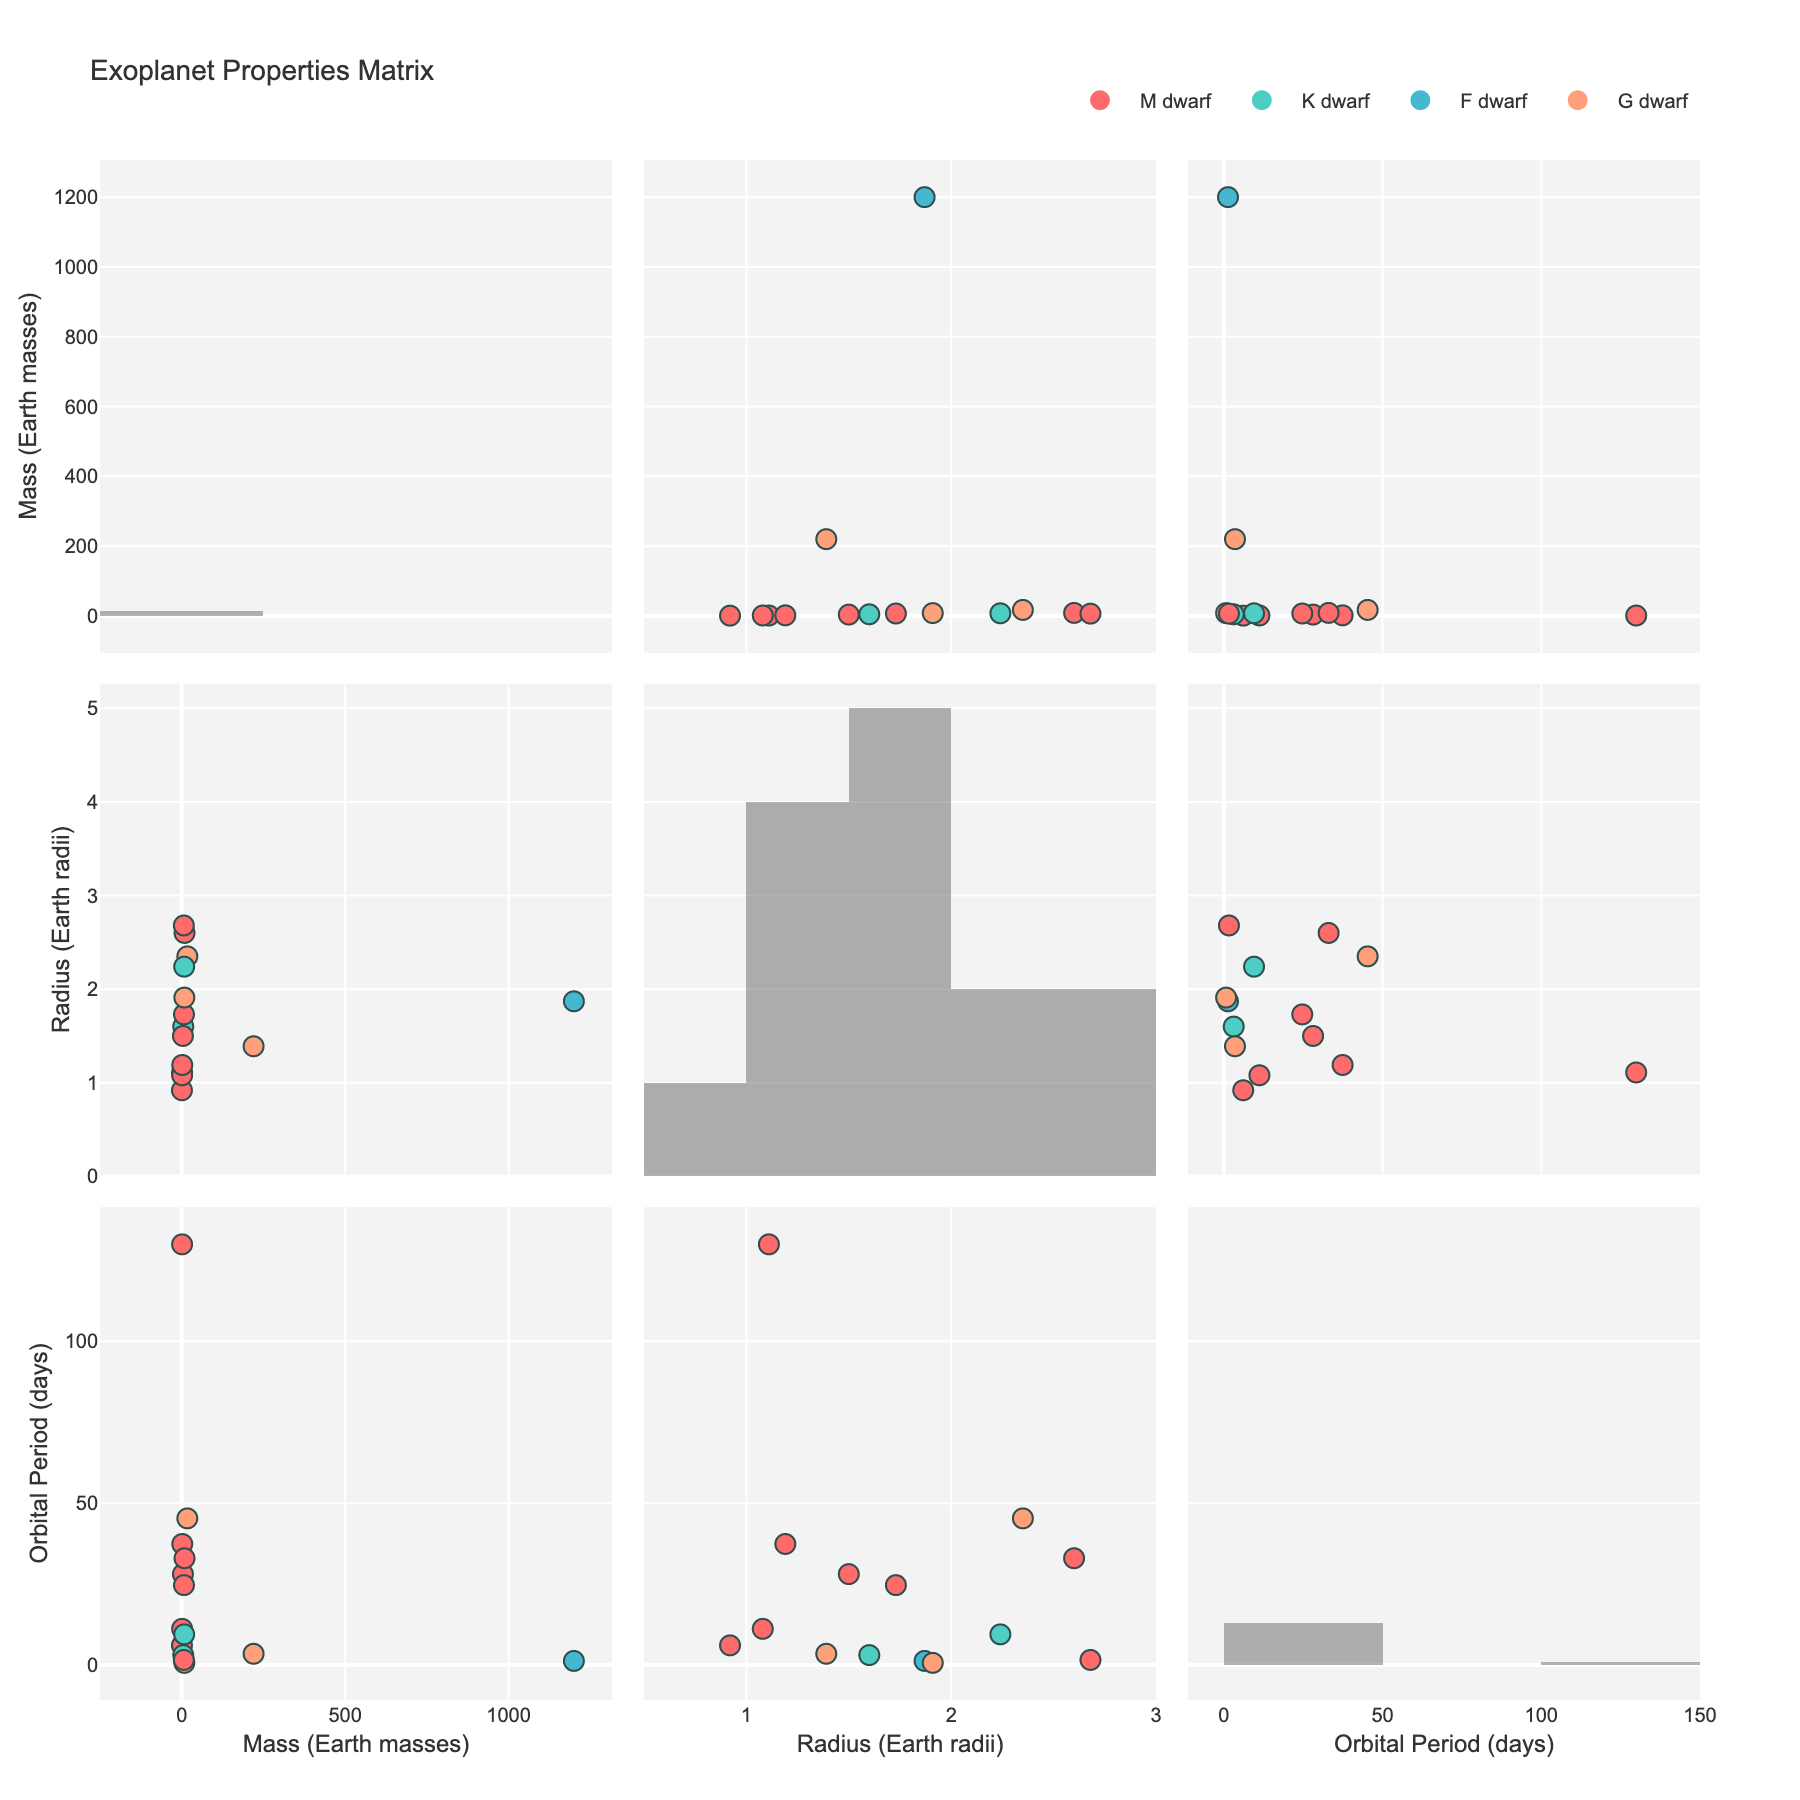what is the title of this plot? The title can be found at the top of the plot and it reads 'Exoplanet Properties Matrix'.
Answer: Exoplanet Properties Matrix How many M dwarf host stars are there? You can identify the M dwarf host stars by looking for the red markers within the figure. Counting these red markers gives the number of M dwarf host stars.
Answer: 9 Which planet has the shortest orbital period? By examining the Orbital Period (days) axis across the scatter plots and finding the smallest value, you can see that the planet with the shortest orbital period is 55 Cancri e.
Answer: 55 Cancri e What is the average radius of exoplanets orbiting G dwarf stars? To find the average radius, locate the exoplanets associated with G dwarf hosts by their color in the figure (peach-colored markers), then calculate the mean of their radii (1.39, 1.91, 2.35). (1.39 + 1.91 + 2.35) / 3 = 1.88.
Answer: 1.88 Which type of host star tends to have exoplanets with larger masses? By comparing the scatter plots for Mass (Earth masses) and different star types, it is noticeable that F dwarfs (light blue markers) tend to have exoplanets with significantly larger masses, particularly WASP-121b.
Answer: F dwarf Are there any exoplanets with an orbital period longer than 100 days? By observing the Orbital Period (days) axis, you can spot the data points that surpass the 100-day mark. Kepler-186f is the planet with an orbital period longer than 100 days.
Answer: Yes, Kepler-186f What is the relationship between the mass and orbital period of exoplanets? The scatter plot comparing Mass (Earth masses) on the x-axis and Orbital Period (days) on the y-axis shows no clear linear relationship between these two properties. The data points are dispersed without a clear pattern.
Answer: No clear relationship Which exoplanet has the highest radius? To determine this, check the Radius (Earth radii) axis across the scatter plots. The largest data point corresponds to K2-18b with a radius of 2.68 Earth radii.
Answer: K2-18b Compare the distribution of radii between M dwarf and G dwarf exoplanets. Which has a larger spread? By observing the scatter plots, the spread of radii for M dwarf exoplanets ranges from approximately 0.92 to 2.68, while G dwarf exoplanets range from about 1.39 to 2.35. M dwarf exoplanets have a more extensive spread in radii.
Answer: M dwarf Is there a correlation between the radius and mass of exoplanets? Inspecting the scatter plot with Mass (Earth masses) on the x-axis and Radius (Earth radii) on the y-axis, it appears there is a general trend that exoplanets with larger masses also tend to have larger radii, indicating a positive correlation.
Answer: Positive correlation 